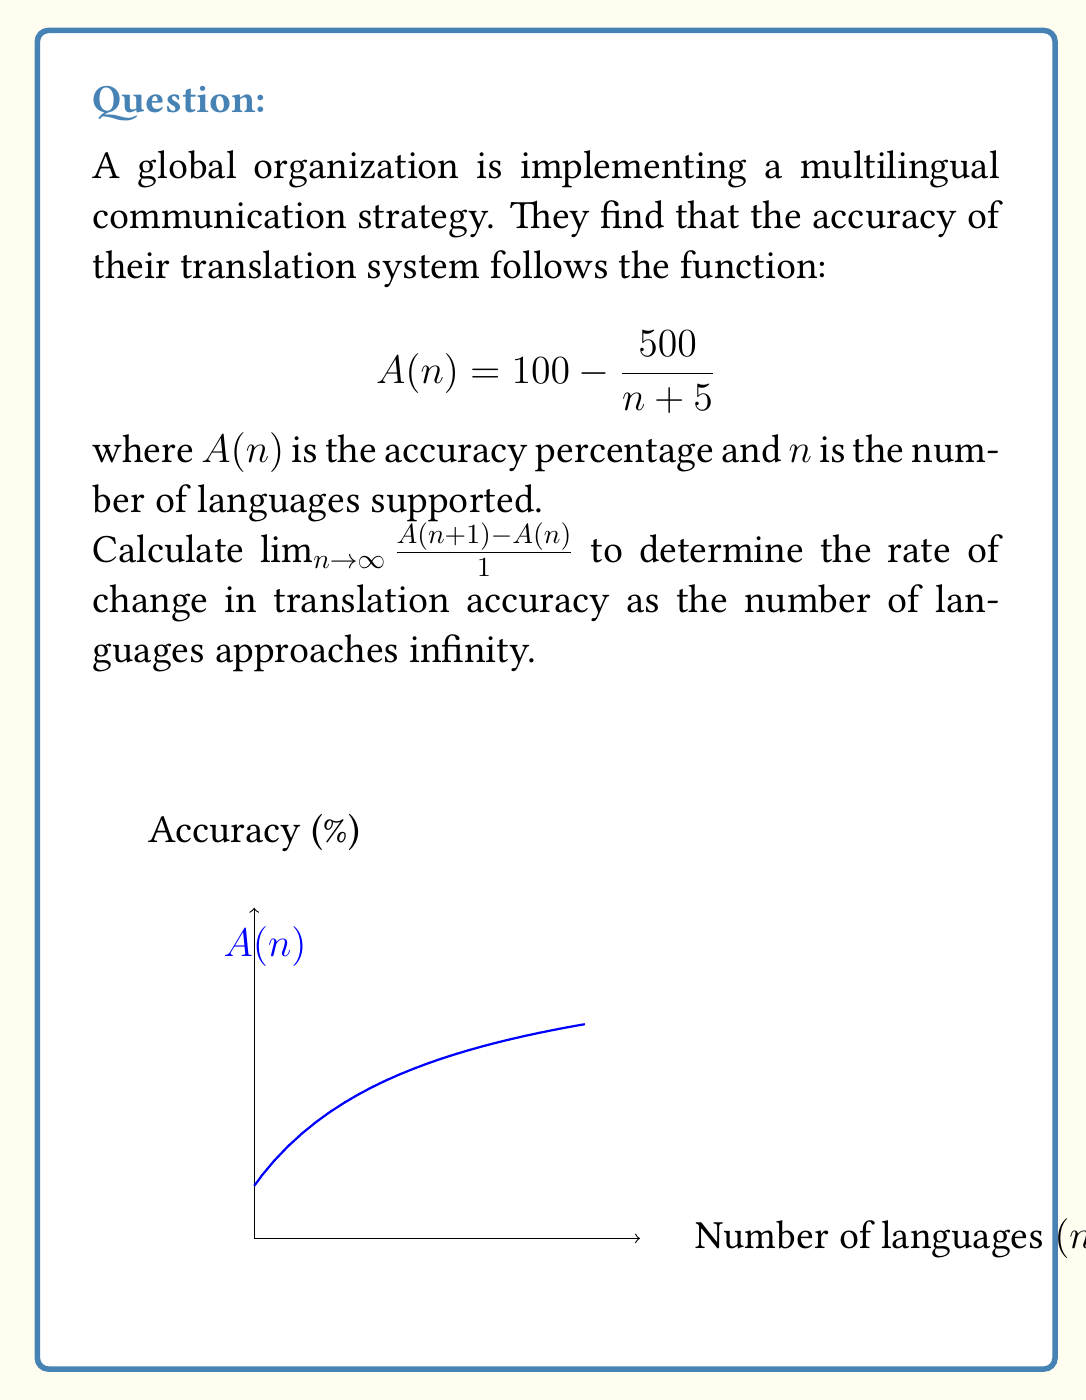Solve this math problem. Let's approach this step-by-step:

1) First, we need to find $A(n+1)$:
   $$A(n+1) = 100 - \frac{500}{(n+1) + 5} = 100 - \frac{500}{n + 6}$$

2) Now, let's set up the difference quotient:
   $$\frac{A(n+1) - A(n)}{1} = \left(100 - \frac{500}{n + 6}\right) - \left(100 - \frac{500}{n + 5}\right)$$

3) Simplify:
   $$\frac{A(n+1) - A(n)}{1} = \frac{500}{n + 5} - \frac{500}{n + 6}$$

4) Find a common denominator:
   $$\frac{A(n+1) - A(n)}{1} = \frac{500(n+6)}{(n+5)(n+6)} - \frac{500(n+5)}{(n+5)(n+6)}$$

5) Simplify:
   $$\frac{A(n+1) - A(n)}{1} = \frac{500(n+6) - 500(n+5)}{(n+5)(n+6)} = \frac{500}{(n+5)(n+6)}$$

6) Now, we need to find the limit as $n$ approaches infinity:
   $$\lim_{n \to \infty} \frac{A(n+1) - A(n)}{1} = \lim_{n \to \infty} \frac{500}{(n+5)(n+6)}$$

7) As $n$ approaches infinity, both $(n+5)$ and $(n+6)$ approach infinity, so:
   $$\lim_{n \to \infty} \frac{500}{(n+5)(n+6)} = \frac{500}{\infty \cdot \infty} = 0$$

Therefore, the rate of change in translation accuracy approaches 0 as the number of languages approaches infinity.
Answer: 0 